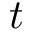Convert formula to latex. <formula><loc_0><loc_0><loc_500><loc_500>t</formula> 